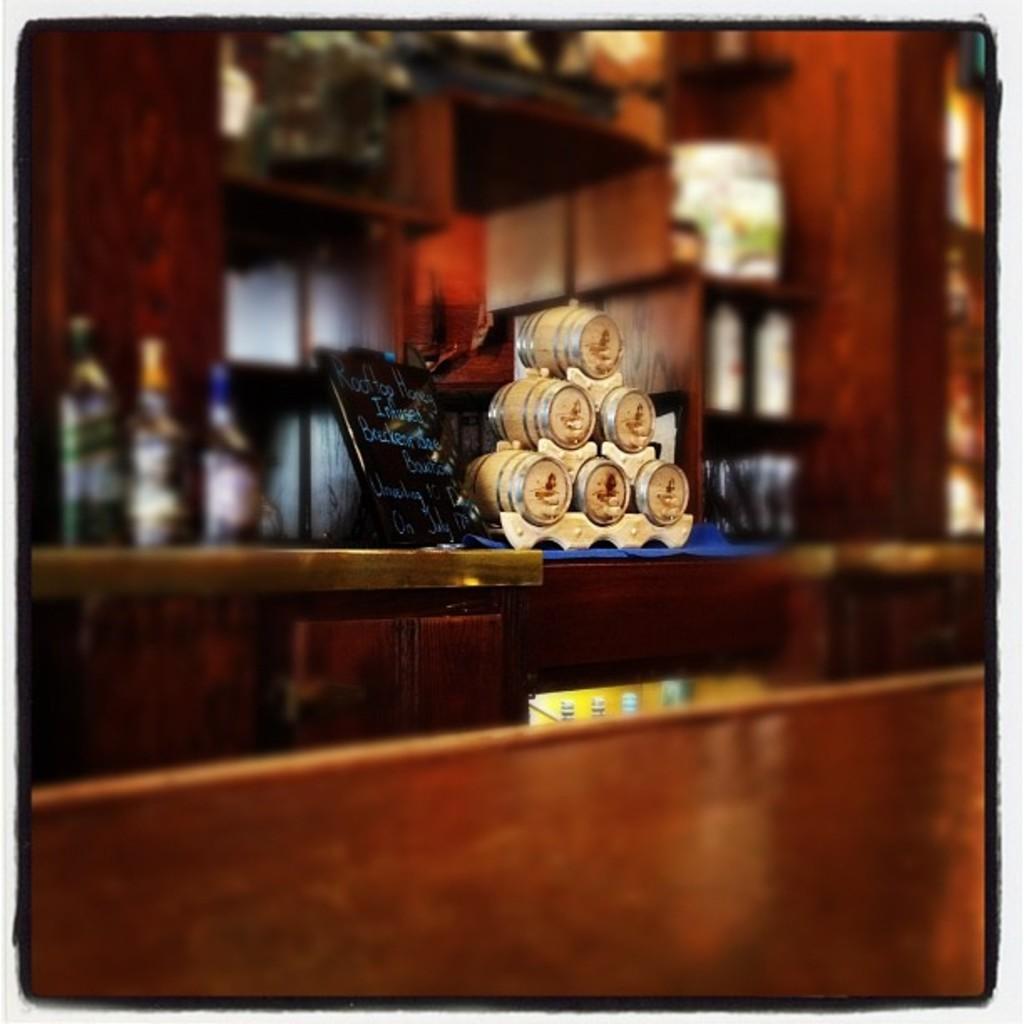Please provide a concise description of this image. As we can see in the image there is a table. On table there is photo frame and bottles. In the background there are cupboards. 